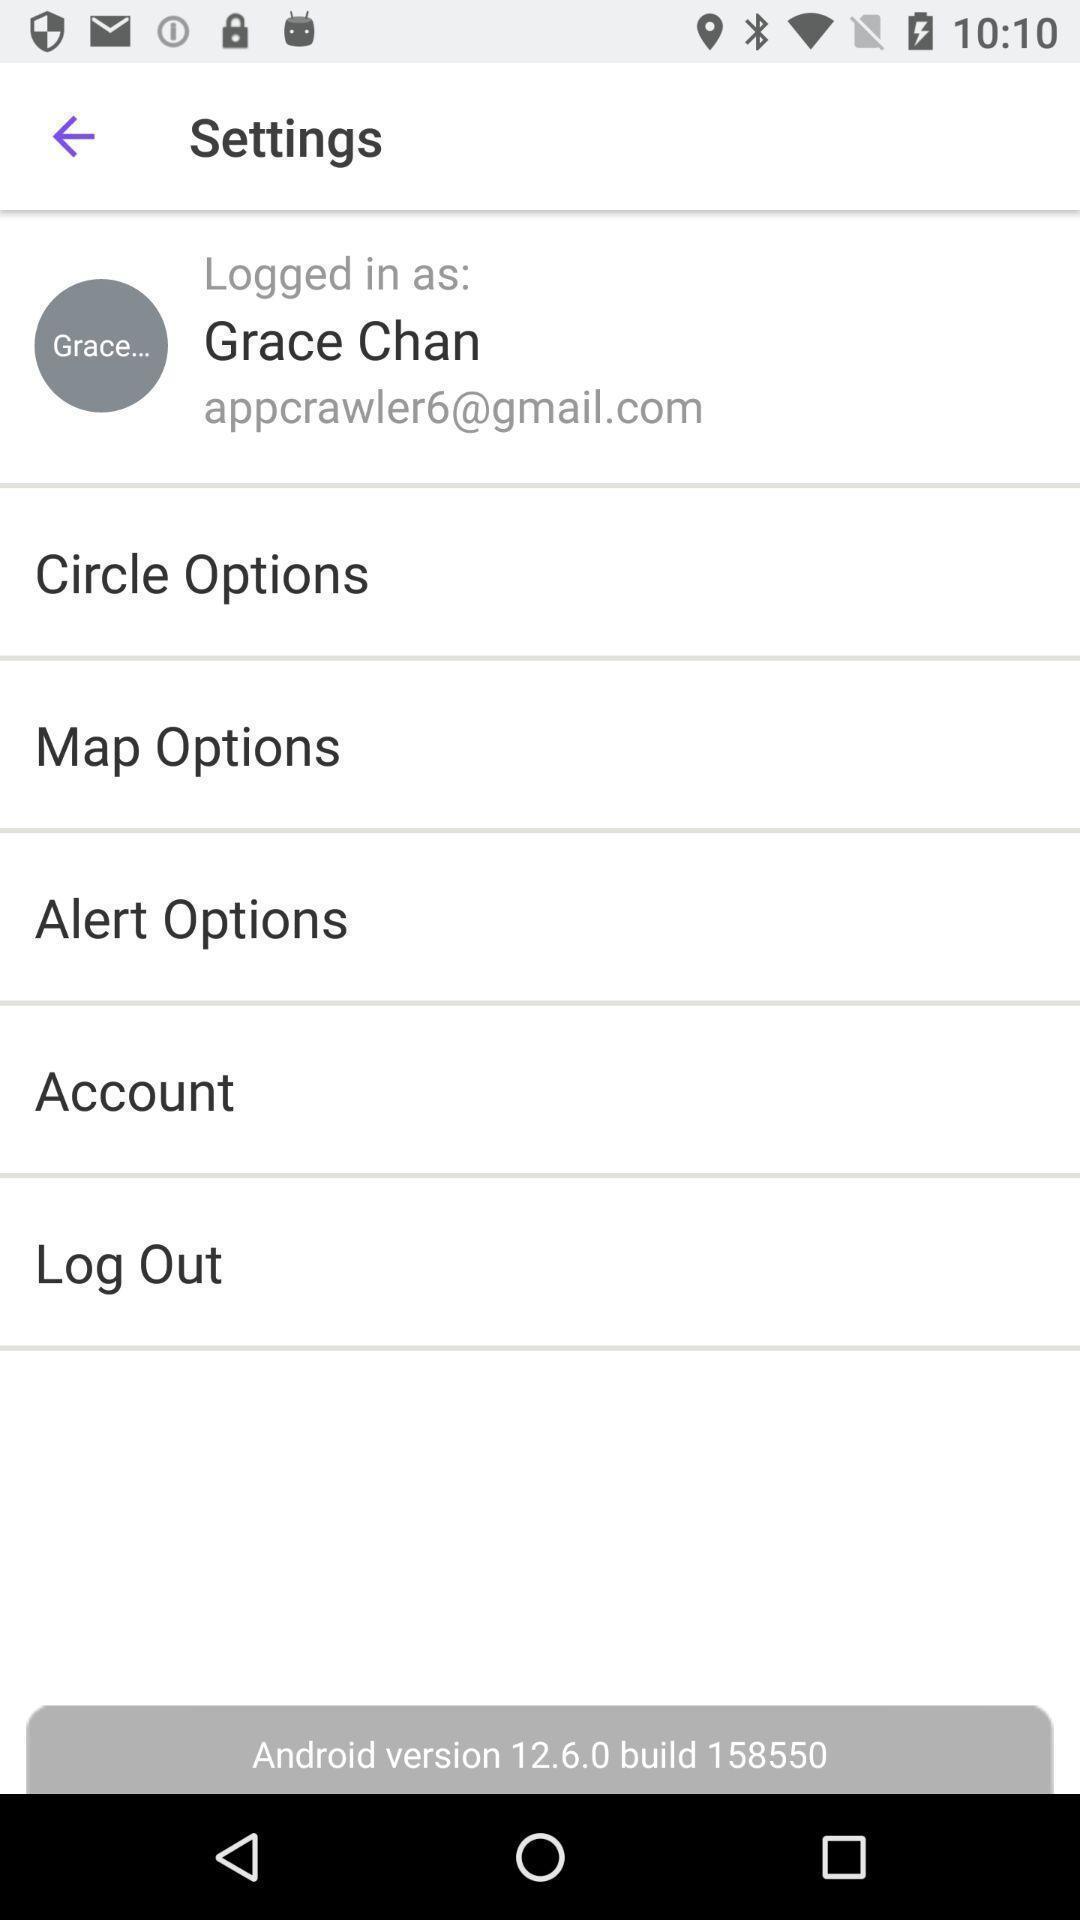Explain what's happening in this screen capture. Screen shows settings of a profile. 